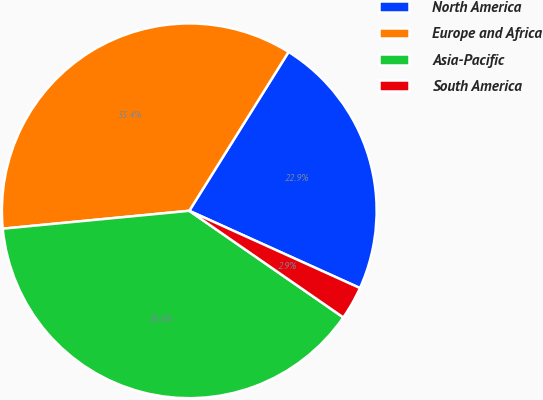Convert chart to OTSL. <chart><loc_0><loc_0><loc_500><loc_500><pie_chart><fcel>North America<fcel>Europe and Africa<fcel>Asia-Pacific<fcel>South America<nl><fcel>22.87%<fcel>35.41%<fcel>38.84%<fcel>2.87%<nl></chart> 